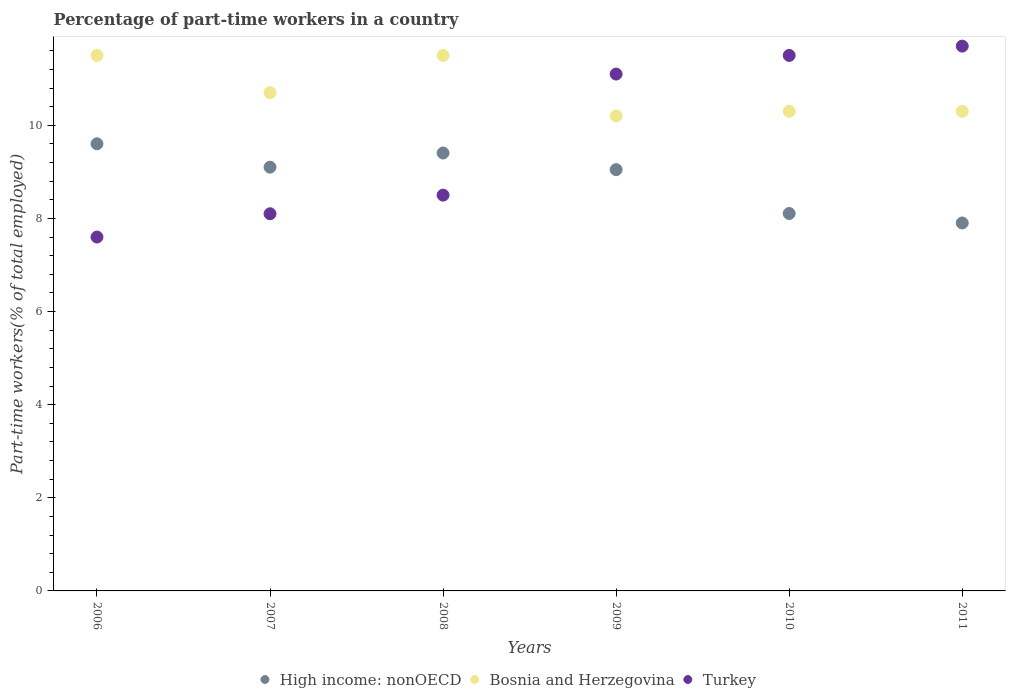What is the percentage of part-time workers in High income: nonOECD in 2007?
Provide a succinct answer. 9.1. Across all years, what is the maximum percentage of part-time workers in High income: nonOECD?
Provide a succinct answer. 9.6. Across all years, what is the minimum percentage of part-time workers in Bosnia and Herzegovina?
Provide a short and direct response. 10.2. In which year was the percentage of part-time workers in High income: nonOECD maximum?
Provide a short and direct response. 2006. What is the total percentage of part-time workers in Bosnia and Herzegovina in the graph?
Offer a terse response. 64.5. What is the difference between the percentage of part-time workers in Turkey in 2007 and that in 2008?
Your response must be concise. -0.4. What is the difference between the percentage of part-time workers in High income: nonOECD in 2011 and the percentage of part-time workers in Bosnia and Herzegovina in 2009?
Provide a succinct answer. -2.3. What is the average percentage of part-time workers in Bosnia and Herzegovina per year?
Your answer should be very brief. 10.75. In the year 2011, what is the difference between the percentage of part-time workers in Turkey and percentage of part-time workers in Bosnia and Herzegovina?
Your answer should be very brief. 1.4. In how many years, is the percentage of part-time workers in Bosnia and Herzegovina greater than 0.8 %?
Make the answer very short. 6. What is the ratio of the percentage of part-time workers in Turkey in 2006 to that in 2010?
Offer a terse response. 0.66. Is the percentage of part-time workers in High income: nonOECD in 2008 less than that in 2010?
Offer a terse response. No. Is the difference between the percentage of part-time workers in Turkey in 2008 and 2010 greater than the difference between the percentage of part-time workers in Bosnia and Herzegovina in 2008 and 2010?
Provide a short and direct response. No. What is the difference between the highest and the second highest percentage of part-time workers in Turkey?
Your answer should be very brief. 0.2. What is the difference between the highest and the lowest percentage of part-time workers in High income: nonOECD?
Provide a succinct answer. 1.7. In how many years, is the percentage of part-time workers in Turkey greater than the average percentage of part-time workers in Turkey taken over all years?
Offer a terse response. 3. Is the sum of the percentage of part-time workers in Turkey in 2008 and 2011 greater than the maximum percentage of part-time workers in Bosnia and Herzegovina across all years?
Your answer should be compact. Yes. Is it the case that in every year, the sum of the percentage of part-time workers in Turkey and percentage of part-time workers in High income: nonOECD  is greater than the percentage of part-time workers in Bosnia and Herzegovina?
Offer a very short reply. Yes. Does the percentage of part-time workers in Bosnia and Herzegovina monotonically increase over the years?
Provide a short and direct response. No. Is the percentage of part-time workers in Turkey strictly greater than the percentage of part-time workers in High income: nonOECD over the years?
Keep it short and to the point. No. How many dotlines are there?
Offer a terse response. 3. How many years are there in the graph?
Make the answer very short. 6. What is the difference between two consecutive major ticks on the Y-axis?
Your answer should be very brief. 2. Does the graph contain any zero values?
Offer a very short reply. No. Where does the legend appear in the graph?
Provide a succinct answer. Bottom center. How many legend labels are there?
Keep it short and to the point. 3. How are the legend labels stacked?
Offer a very short reply. Horizontal. What is the title of the graph?
Give a very brief answer. Percentage of part-time workers in a country. Does "Central Europe" appear as one of the legend labels in the graph?
Provide a short and direct response. No. What is the label or title of the Y-axis?
Your answer should be compact. Part-time workers(% of total employed). What is the Part-time workers(% of total employed) of High income: nonOECD in 2006?
Make the answer very short. 9.6. What is the Part-time workers(% of total employed) of Turkey in 2006?
Give a very brief answer. 7.6. What is the Part-time workers(% of total employed) in High income: nonOECD in 2007?
Offer a very short reply. 9.1. What is the Part-time workers(% of total employed) of Bosnia and Herzegovina in 2007?
Keep it short and to the point. 10.7. What is the Part-time workers(% of total employed) in Turkey in 2007?
Offer a terse response. 8.1. What is the Part-time workers(% of total employed) in High income: nonOECD in 2008?
Provide a short and direct response. 9.4. What is the Part-time workers(% of total employed) in Bosnia and Herzegovina in 2008?
Offer a very short reply. 11.5. What is the Part-time workers(% of total employed) of Turkey in 2008?
Keep it short and to the point. 8.5. What is the Part-time workers(% of total employed) in High income: nonOECD in 2009?
Offer a very short reply. 9.05. What is the Part-time workers(% of total employed) of Bosnia and Herzegovina in 2009?
Ensure brevity in your answer.  10.2. What is the Part-time workers(% of total employed) in Turkey in 2009?
Your answer should be compact. 11.1. What is the Part-time workers(% of total employed) in High income: nonOECD in 2010?
Provide a short and direct response. 8.11. What is the Part-time workers(% of total employed) of Bosnia and Herzegovina in 2010?
Make the answer very short. 10.3. What is the Part-time workers(% of total employed) of Turkey in 2010?
Keep it short and to the point. 11.5. What is the Part-time workers(% of total employed) in High income: nonOECD in 2011?
Your response must be concise. 7.9. What is the Part-time workers(% of total employed) of Bosnia and Herzegovina in 2011?
Offer a very short reply. 10.3. What is the Part-time workers(% of total employed) of Turkey in 2011?
Provide a short and direct response. 11.7. Across all years, what is the maximum Part-time workers(% of total employed) in High income: nonOECD?
Give a very brief answer. 9.6. Across all years, what is the maximum Part-time workers(% of total employed) in Bosnia and Herzegovina?
Your answer should be compact. 11.5. Across all years, what is the maximum Part-time workers(% of total employed) in Turkey?
Offer a very short reply. 11.7. Across all years, what is the minimum Part-time workers(% of total employed) in High income: nonOECD?
Keep it short and to the point. 7.9. Across all years, what is the minimum Part-time workers(% of total employed) in Bosnia and Herzegovina?
Ensure brevity in your answer.  10.2. Across all years, what is the minimum Part-time workers(% of total employed) of Turkey?
Provide a succinct answer. 7.6. What is the total Part-time workers(% of total employed) of High income: nonOECD in the graph?
Make the answer very short. 53.16. What is the total Part-time workers(% of total employed) of Bosnia and Herzegovina in the graph?
Keep it short and to the point. 64.5. What is the total Part-time workers(% of total employed) of Turkey in the graph?
Ensure brevity in your answer.  58.5. What is the difference between the Part-time workers(% of total employed) of High income: nonOECD in 2006 and that in 2007?
Your answer should be compact. 0.5. What is the difference between the Part-time workers(% of total employed) in Bosnia and Herzegovina in 2006 and that in 2007?
Offer a very short reply. 0.8. What is the difference between the Part-time workers(% of total employed) of High income: nonOECD in 2006 and that in 2008?
Your response must be concise. 0.2. What is the difference between the Part-time workers(% of total employed) in Bosnia and Herzegovina in 2006 and that in 2008?
Give a very brief answer. 0. What is the difference between the Part-time workers(% of total employed) in Turkey in 2006 and that in 2008?
Offer a terse response. -0.9. What is the difference between the Part-time workers(% of total employed) of High income: nonOECD in 2006 and that in 2009?
Provide a succinct answer. 0.56. What is the difference between the Part-time workers(% of total employed) of High income: nonOECD in 2006 and that in 2010?
Keep it short and to the point. 1.5. What is the difference between the Part-time workers(% of total employed) in High income: nonOECD in 2006 and that in 2011?
Give a very brief answer. 1.7. What is the difference between the Part-time workers(% of total employed) of High income: nonOECD in 2007 and that in 2008?
Offer a terse response. -0.3. What is the difference between the Part-time workers(% of total employed) in Bosnia and Herzegovina in 2007 and that in 2008?
Provide a short and direct response. -0.8. What is the difference between the Part-time workers(% of total employed) of Turkey in 2007 and that in 2008?
Ensure brevity in your answer.  -0.4. What is the difference between the Part-time workers(% of total employed) of High income: nonOECD in 2007 and that in 2009?
Provide a short and direct response. 0.05. What is the difference between the Part-time workers(% of total employed) in Bosnia and Herzegovina in 2007 and that in 2009?
Your answer should be compact. 0.5. What is the difference between the Part-time workers(% of total employed) of Turkey in 2007 and that in 2009?
Your answer should be compact. -3. What is the difference between the Part-time workers(% of total employed) in High income: nonOECD in 2007 and that in 2010?
Keep it short and to the point. 0.99. What is the difference between the Part-time workers(% of total employed) in High income: nonOECD in 2007 and that in 2011?
Your answer should be very brief. 1.2. What is the difference between the Part-time workers(% of total employed) in Bosnia and Herzegovina in 2007 and that in 2011?
Offer a very short reply. 0.4. What is the difference between the Part-time workers(% of total employed) in Turkey in 2007 and that in 2011?
Keep it short and to the point. -3.6. What is the difference between the Part-time workers(% of total employed) of High income: nonOECD in 2008 and that in 2009?
Offer a very short reply. 0.36. What is the difference between the Part-time workers(% of total employed) in Turkey in 2008 and that in 2009?
Offer a terse response. -2.6. What is the difference between the Part-time workers(% of total employed) in High income: nonOECD in 2008 and that in 2010?
Your answer should be compact. 1.3. What is the difference between the Part-time workers(% of total employed) in High income: nonOECD in 2008 and that in 2011?
Your response must be concise. 1.5. What is the difference between the Part-time workers(% of total employed) of High income: nonOECD in 2009 and that in 2010?
Offer a terse response. 0.94. What is the difference between the Part-time workers(% of total employed) of Turkey in 2009 and that in 2010?
Provide a short and direct response. -0.4. What is the difference between the Part-time workers(% of total employed) in High income: nonOECD in 2009 and that in 2011?
Provide a short and direct response. 1.15. What is the difference between the Part-time workers(% of total employed) in Bosnia and Herzegovina in 2009 and that in 2011?
Make the answer very short. -0.1. What is the difference between the Part-time workers(% of total employed) of High income: nonOECD in 2010 and that in 2011?
Keep it short and to the point. 0.2. What is the difference between the Part-time workers(% of total employed) of Bosnia and Herzegovina in 2010 and that in 2011?
Your answer should be compact. 0. What is the difference between the Part-time workers(% of total employed) of High income: nonOECD in 2006 and the Part-time workers(% of total employed) of Bosnia and Herzegovina in 2007?
Offer a terse response. -1.1. What is the difference between the Part-time workers(% of total employed) of High income: nonOECD in 2006 and the Part-time workers(% of total employed) of Turkey in 2007?
Offer a terse response. 1.5. What is the difference between the Part-time workers(% of total employed) of Bosnia and Herzegovina in 2006 and the Part-time workers(% of total employed) of Turkey in 2007?
Give a very brief answer. 3.4. What is the difference between the Part-time workers(% of total employed) of High income: nonOECD in 2006 and the Part-time workers(% of total employed) of Bosnia and Herzegovina in 2008?
Provide a short and direct response. -1.9. What is the difference between the Part-time workers(% of total employed) of High income: nonOECD in 2006 and the Part-time workers(% of total employed) of Turkey in 2008?
Give a very brief answer. 1.1. What is the difference between the Part-time workers(% of total employed) in Bosnia and Herzegovina in 2006 and the Part-time workers(% of total employed) in Turkey in 2008?
Your response must be concise. 3. What is the difference between the Part-time workers(% of total employed) in High income: nonOECD in 2006 and the Part-time workers(% of total employed) in Bosnia and Herzegovina in 2009?
Make the answer very short. -0.6. What is the difference between the Part-time workers(% of total employed) in High income: nonOECD in 2006 and the Part-time workers(% of total employed) in Turkey in 2009?
Your answer should be compact. -1.5. What is the difference between the Part-time workers(% of total employed) of High income: nonOECD in 2006 and the Part-time workers(% of total employed) of Bosnia and Herzegovina in 2010?
Provide a succinct answer. -0.7. What is the difference between the Part-time workers(% of total employed) in High income: nonOECD in 2006 and the Part-time workers(% of total employed) in Turkey in 2010?
Make the answer very short. -1.9. What is the difference between the Part-time workers(% of total employed) in High income: nonOECD in 2006 and the Part-time workers(% of total employed) in Bosnia and Herzegovina in 2011?
Give a very brief answer. -0.7. What is the difference between the Part-time workers(% of total employed) of High income: nonOECD in 2006 and the Part-time workers(% of total employed) of Turkey in 2011?
Keep it short and to the point. -2.1. What is the difference between the Part-time workers(% of total employed) in High income: nonOECD in 2007 and the Part-time workers(% of total employed) in Bosnia and Herzegovina in 2008?
Your answer should be very brief. -2.4. What is the difference between the Part-time workers(% of total employed) of High income: nonOECD in 2007 and the Part-time workers(% of total employed) of Turkey in 2008?
Give a very brief answer. 0.6. What is the difference between the Part-time workers(% of total employed) of Bosnia and Herzegovina in 2007 and the Part-time workers(% of total employed) of Turkey in 2008?
Your answer should be very brief. 2.2. What is the difference between the Part-time workers(% of total employed) of High income: nonOECD in 2007 and the Part-time workers(% of total employed) of Bosnia and Herzegovina in 2009?
Offer a terse response. -1.1. What is the difference between the Part-time workers(% of total employed) of High income: nonOECD in 2007 and the Part-time workers(% of total employed) of Turkey in 2009?
Provide a short and direct response. -2. What is the difference between the Part-time workers(% of total employed) in Bosnia and Herzegovina in 2007 and the Part-time workers(% of total employed) in Turkey in 2009?
Provide a short and direct response. -0.4. What is the difference between the Part-time workers(% of total employed) of High income: nonOECD in 2007 and the Part-time workers(% of total employed) of Bosnia and Herzegovina in 2010?
Keep it short and to the point. -1.2. What is the difference between the Part-time workers(% of total employed) of High income: nonOECD in 2007 and the Part-time workers(% of total employed) of Turkey in 2010?
Give a very brief answer. -2.4. What is the difference between the Part-time workers(% of total employed) in Bosnia and Herzegovina in 2007 and the Part-time workers(% of total employed) in Turkey in 2010?
Your answer should be compact. -0.8. What is the difference between the Part-time workers(% of total employed) in High income: nonOECD in 2007 and the Part-time workers(% of total employed) in Bosnia and Herzegovina in 2011?
Your answer should be compact. -1.2. What is the difference between the Part-time workers(% of total employed) in High income: nonOECD in 2007 and the Part-time workers(% of total employed) in Turkey in 2011?
Make the answer very short. -2.6. What is the difference between the Part-time workers(% of total employed) in Bosnia and Herzegovina in 2007 and the Part-time workers(% of total employed) in Turkey in 2011?
Offer a very short reply. -1. What is the difference between the Part-time workers(% of total employed) in High income: nonOECD in 2008 and the Part-time workers(% of total employed) in Bosnia and Herzegovina in 2009?
Provide a short and direct response. -0.8. What is the difference between the Part-time workers(% of total employed) in High income: nonOECD in 2008 and the Part-time workers(% of total employed) in Turkey in 2009?
Make the answer very short. -1.7. What is the difference between the Part-time workers(% of total employed) of Bosnia and Herzegovina in 2008 and the Part-time workers(% of total employed) of Turkey in 2009?
Your answer should be compact. 0.4. What is the difference between the Part-time workers(% of total employed) of High income: nonOECD in 2008 and the Part-time workers(% of total employed) of Bosnia and Herzegovina in 2010?
Ensure brevity in your answer.  -0.9. What is the difference between the Part-time workers(% of total employed) of High income: nonOECD in 2008 and the Part-time workers(% of total employed) of Turkey in 2010?
Your response must be concise. -2.1. What is the difference between the Part-time workers(% of total employed) in High income: nonOECD in 2008 and the Part-time workers(% of total employed) in Bosnia and Herzegovina in 2011?
Make the answer very short. -0.9. What is the difference between the Part-time workers(% of total employed) of High income: nonOECD in 2008 and the Part-time workers(% of total employed) of Turkey in 2011?
Give a very brief answer. -2.3. What is the difference between the Part-time workers(% of total employed) of High income: nonOECD in 2009 and the Part-time workers(% of total employed) of Bosnia and Herzegovina in 2010?
Make the answer very short. -1.25. What is the difference between the Part-time workers(% of total employed) of High income: nonOECD in 2009 and the Part-time workers(% of total employed) of Turkey in 2010?
Provide a succinct answer. -2.45. What is the difference between the Part-time workers(% of total employed) in Bosnia and Herzegovina in 2009 and the Part-time workers(% of total employed) in Turkey in 2010?
Give a very brief answer. -1.3. What is the difference between the Part-time workers(% of total employed) of High income: nonOECD in 2009 and the Part-time workers(% of total employed) of Bosnia and Herzegovina in 2011?
Your answer should be very brief. -1.25. What is the difference between the Part-time workers(% of total employed) in High income: nonOECD in 2009 and the Part-time workers(% of total employed) in Turkey in 2011?
Your response must be concise. -2.65. What is the difference between the Part-time workers(% of total employed) of Bosnia and Herzegovina in 2009 and the Part-time workers(% of total employed) of Turkey in 2011?
Keep it short and to the point. -1.5. What is the difference between the Part-time workers(% of total employed) of High income: nonOECD in 2010 and the Part-time workers(% of total employed) of Bosnia and Herzegovina in 2011?
Make the answer very short. -2.19. What is the difference between the Part-time workers(% of total employed) of High income: nonOECD in 2010 and the Part-time workers(% of total employed) of Turkey in 2011?
Provide a succinct answer. -3.59. What is the difference between the Part-time workers(% of total employed) of Bosnia and Herzegovina in 2010 and the Part-time workers(% of total employed) of Turkey in 2011?
Make the answer very short. -1.4. What is the average Part-time workers(% of total employed) in High income: nonOECD per year?
Ensure brevity in your answer.  8.86. What is the average Part-time workers(% of total employed) of Bosnia and Herzegovina per year?
Your response must be concise. 10.75. What is the average Part-time workers(% of total employed) in Turkey per year?
Your answer should be compact. 9.75. In the year 2006, what is the difference between the Part-time workers(% of total employed) of High income: nonOECD and Part-time workers(% of total employed) of Bosnia and Herzegovina?
Provide a short and direct response. -1.9. In the year 2006, what is the difference between the Part-time workers(% of total employed) of High income: nonOECD and Part-time workers(% of total employed) of Turkey?
Ensure brevity in your answer.  2. In the year 2006, what is the difference between the Part-time workers(% of total employed) in Bosnia and Herzegovina and Part-time workers(% of total employed) in Turkey?
Your answer should be very brief. 3.9. In the year 2007, what is the difference between the Part-time workers(% of total employed) in High income: nonOECD and Part-time workers(% of total employed) in Bosnia and Herzegovina?
Offer a terse response. -1.6. In the year 2007, what is the difference between the Part-time workers(% of total employed) in High income: nonOECD and Part-time workers(% of total employed) in Turkey?
Offer a terse response. 1. In the year 2007, what is the difference between the Part-time workers(% of total employed) of Bosnia and Herzegovina and Part-time workers(% of total employed) of Turkey?
Your response must be concise. 2.6. In the year 2008, what is the difference between the Part-time workers(% of total employed) of High income: nonOECD and Part-time workers(% of total employed) of Bosnia and Herzegovina?
Offer a terse response. -2.1. In the year 2008, what is the difference between the Part-time workers(% of total employed) of High income: nonOECD and Part-time workers(% of total employed) of Turkey?
Offer a very short reply. 0.9. In the year 2008, what is the difference between the Part-time workers(% of total employed) of Bosnia and Herzegovina and Part-time workers(% of total employed) of Turkey?
Your answer should be compact. 3. In the year 2009, what is the difference between the Part-time workers(% of total employed) in High income: nonOECD and Part-time workers(% of total employed) in Bosnia and Herzegovina?
Your answer should be very brief. -1.15. In the year 2009, what is the difference between the Part-time workers(% of total employed) of High income: nonOECD and Part-time workers(% of total employed) of Turkey?
Offer a very short reply. -2.05. In the year 2009, what is the difference between the Part-time workers(% of total employed) in Bosnia and Herzegovina and Part-time workers(% of total employed) in Turkey?
Offer a terse response. -0.9. In the year 2010, what is the difference between the Part-time workers(% of total employed) of High income: nonOECD and Part-time workers(% of total employed) of Bosnia and Herzegovina?
Keep it short and to the point. -2.19. In the year 2010, what is the difference between the Part-time workers(% of total employed) of High income: nonOECD and Part-time workers(% of total employed) of Turkey?
Your response must be concise. -3.39. In the year 2011, what is the difference between the Part-time workers(% of total employed) in High income: nonOECD and Part-time workers(% of total employed) in Bosnia and Herzegovina?
Make the answer very short. -2.4. In the year 2011, what is the difference between the Part-time workers(% of total employed) in High income: nonOECD and Part-time workers(% of total employed) in Turkey?
Your response must be concise. -3.8. What is the ratio of the Part-time workers(% of total employed) of High income: nonOECD in 2006 to that in 2007?
Ensure brevity in your answer.  1.06. What is the ratio of the Part-time workers(% of total employed) of Bosnia and Herzegovina in 2006 to that in 2007?
Your response must be concise. 1.07. What is the ratio of the Part-time workers(% of total employed) in Turkey in 2006 to that in 2007?
Make the answer very short. 0.94. What is the ratio of the Part-time workers(% of total employed) in High income: nonOECD in 2006 to that in 2008?
Keep it short and to the point. 1.02. What is the ratio of the Part-time workers(% of total employed) in Turkey in 2006 to that in 2008?
Make the answer very short. 0.89. What is the ratio of the Part-time workers(% of total employed) of High income: nonOECD in 2006 to that in 2009?
Your response must be concise. 1.06. What is the ratio of the Part-time workers(% of total employed) in Bosnia and Herzegovina in 2006 to that in 2009?
Give a very brief answer. 1.13. What is the ratio of the Part-time workers(% of total employed) in Turkey in 2006 to that in 2009?
Your response must be concise. 0.68. What is the ratio of the Part-time workers(% of total employed) of High income: nonOECD in 2006 to that in 2010?
Give a very brief answer. 1.18. What is the ratio of the Part-time workers(% of total employed) of Bosnia and Herzegovina in 2006 to that in 2010?
Your answer should be compact. 1.12. What is the ratio of the Part-time workers(% of total employed) of Turkey in 2006 to that in 2010?
Your answer should be very brief. 0.66. What is the ratio of the Part-time workers(% of total employed) in High income: nonOECD in 2006 to that in 2011?
Ensure brevity in your answer.  1.22. What is the ratio of the Part-time workers(% of total employed) of Bosnia and Herzegovina in 2006 to that in 2011?
Make the answer very short. 1.12. What is the ratio of the Part-time workers(% of total employed) of Turkey in 2006 to that in 2011?
Keep it short and to the point. 0.65. What is the ratio of the Part-time workers(% of total employed) in High income: nonOECD in 2007 to that in 2008?
Ensure brevity in your answer.  0.97. What is the ratio of the Part-time workers(% of total employed) in Bosnia and Herzegovina in 2007 to that in 2008?
Your response must be concise. 0.93. What is the ratio of the Part-time workers(% of total employed) in Turkey in 2007 to that in 2008?
Your response must be concise. 0.95. What is the ratio of the Part-time workers(% of total employed) in High income: nonOECD in 2007 to that in 2009?
Ensure brevity in your answer.  1.01. What is the ratio of the Part-time workers(% of total employed) in Bosnia and Herzegovina in 2007 to that in 2009?
Offer a very short reply. 1.05. What is the ratio of the Part-time workers(% of total employed) in Turkey in 2007 to that in 2009?
Make the answer very short. 0.73. What is the ratio of the Part-time workers(% of total employed) of High income: nonOECD in 2007 to that in 2010?
Offer a terse response. 1.12. What is the ratio of the Part-time workers(% of total employed) in Bosnia and Herzegovina in 2007 to that in 2010?
Your answer should be compact. 1.04. What is the ratio of the Part-time workers(% of total employed) in Turkey in 2007 to that in 2010?
Give a very brief answer. 0.7. What is the ratio of the Part-time workers(% of total employed) of High income: nonOECD in 2007 to that in 2011?
Ensure brevity in your answer.  1.15. What is the ratio of the Part-time workers(% of total employed) of Bosnia and Herzegovina in 2007 to that in 2011?
Give a very brief answer. 1.04. What is the ratio of the Part-time workers(% of total employed) in Turkey in 2007 to that in 2011?
Offer a terse response. 0.69. What is the ratio of the Part-time workers(% of total employed) of High income: nonOECD in 2008 to that in 2009?
Make the answer very short. 1.04. What is the ratio of the Part-time workers(% of total employed) in Bosnia and Herzegovina in 2008 to that in 2009?
Offer a terse response. 1.13. What is the ratio of the Part-time workers(% of total employed) of Turkey in 2008 to that in 2009?
Offer a very short reply. 0.77. What is the ratio of the Part-time workers(% of total employed) of High income: nonOECD in 2008 to that in 2010?
Make the answer very short. 1.16. What is the ratio of the Part-time workers(% of total employed) of Bosnia and Herzegovina in 2008 to that in 2010?
Your response must be concise. 1.12. What is the ratio of the Part-time workers(% of total employed) in Turkey in 2008 to that in 2010?
Keep it short and to the point. 0.74. What is the ratio of the Part-time workers(% of total employed) in High income: nonOECD in 2008 to that in 2011?
Provide a short and direct response. 1.19. What is the ratio of the Part-time workers(% of total employed) in Bosnia and Herzegovina in 2008 to that in 2011?
Your answer should be very brief. 1.12. What is the ratio of the Part-time workers(% of total employed) of Turkey in 2008 to that in 2011?
Offer a terse response. 0.73. What is the ratio of the Part-time workers(% of total employed) of High income: nonOECD in 2009 to that in 2010?
Offer a very short reply. 1.12. What is the ratio of the Part-time workers(% of total employed) in Bosnia and Herzegovina in 2009 to that in 2010?
Keep it short and to the point. 0.99. What is the ratio of the Part-time workers(% of total employed) of Turkey in 2009 to that in 2010?
Your response must be concise. 0.97. What is the ratio of the Part-time workers(% of total employed) in High income: nonOECD in 2009 to that in 2011?
Offer a very short reply. 1.15. What is the ratio of the Part-time workers(% of total employed) of Bosnia and Herzegovina in 2009 to that in 2011?
Your answer should be very brief. 0.99. What is the ratio of the Part-time workers(% of total employed) in Turkey in 2009 to that in 2011?
Your response must be concise. 0.95. What is the ratio of the Part-time workers(% of total employed) of High income: nonOECD in 2010 to that in 2011?
Give a very brief answer. 1.03. What is the ratio of the Part-time workers(% of total employed) of Turkey in 2010 to that in 2011?
Provide a succinct answer. 0.98. What is the difference between the highest and the second highest Part-time workers(% of total employed) of High income: nonOECD?
Offer a very short reply. 0.2. What is the difference between the highest and the lowest Part-time workers(% of total employed) of High income: nonOECD?
Ensure brevity in your answer.  1.7. What is the difference between the highest and the lowest Part-time workers(% of total employed) of Bosnia and Herzegovina?
Offer a very short reply. 1.3. 